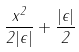Convert formula to latex. <formula><loc_0><loc_0><loc_500><loc_500>\frac { x ^ { 2 } } { 2 | \epsilon | } + \frac { | \epsilon | } { 2 }</formula> 